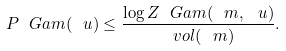<formula> <loc_0><loc_0><loc_500><loc_500>P _ { \ } G a m ( \ u ) \leq \frac { \log Z _ { \ } G a m ( \ m , \ u ) } { \ v o l ( \ m ) } .</formula> 